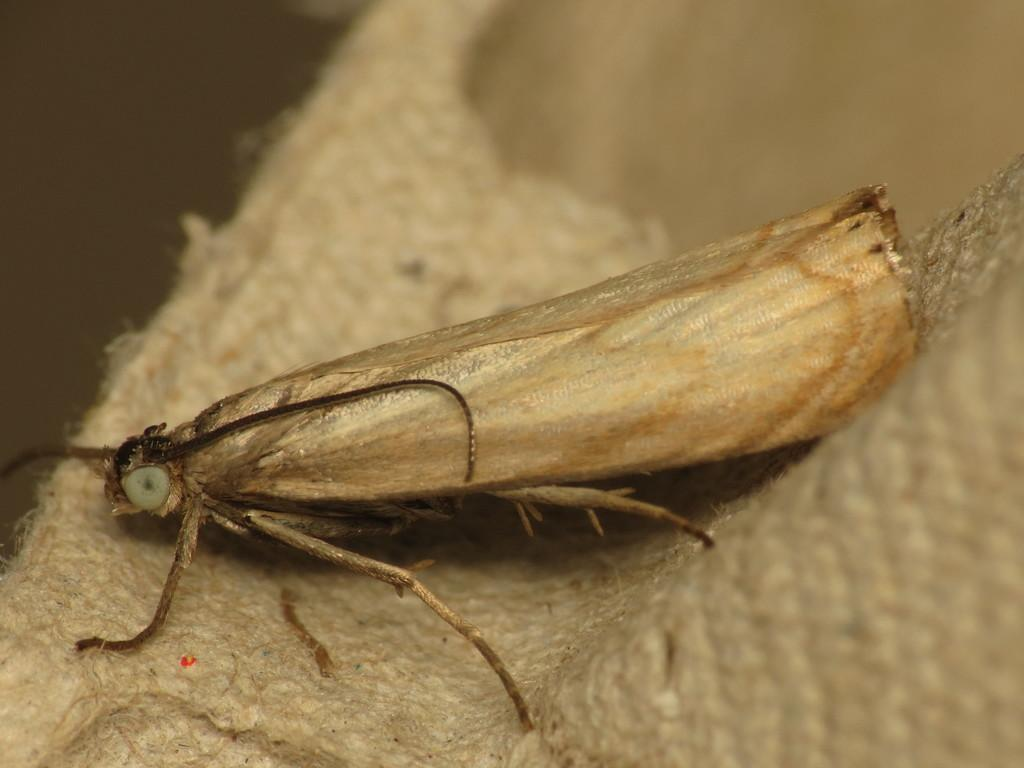What type of creature is in the picture? There is an insect in the picture. What color is the insect? The insect is cream in color. What body parts does the insect have? The insect has legs, eyes, and antenna. Where is the insect located in the image? The insect is on a mat. What type of shop can be seen on the page in the image? There is no shop or page present in the image; it features an insect on a mat. How many noses does the insect have in the image? Insects do not have noses, so this question cannot be answered based on the image. 